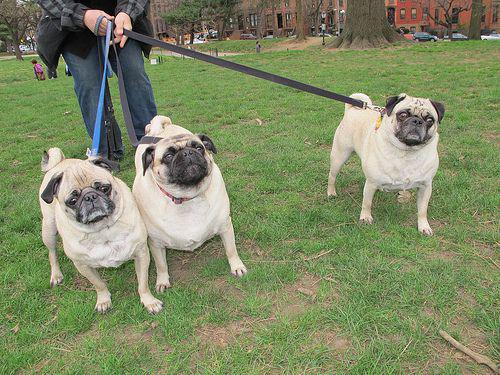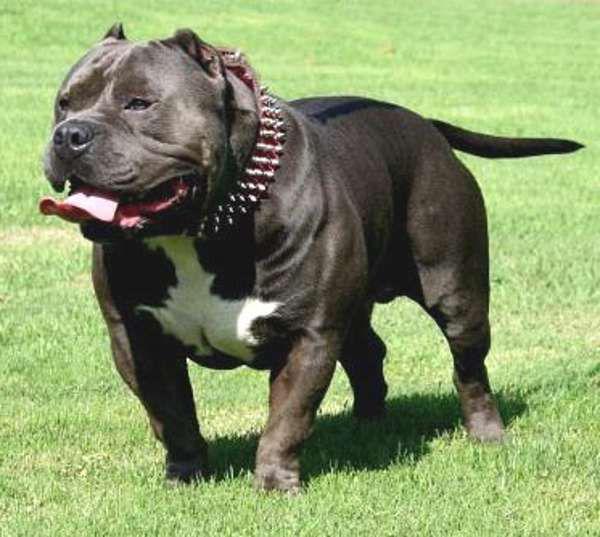The first image is the image on the left, the second image is the image on the right. Evaluate the accuracy of this statement regarding the images: "The right image contains no more than one dog.". Is it true? Answer yes or no. Yes. The first image is the image on the left, the second image is the image on the right. Considering the images on both sides, is "Three buff-beige pugs are side-by-side on the grass in one image, and one dog standing and wearing a collar is in the other image." valid? Answer yes or no. Yes. 